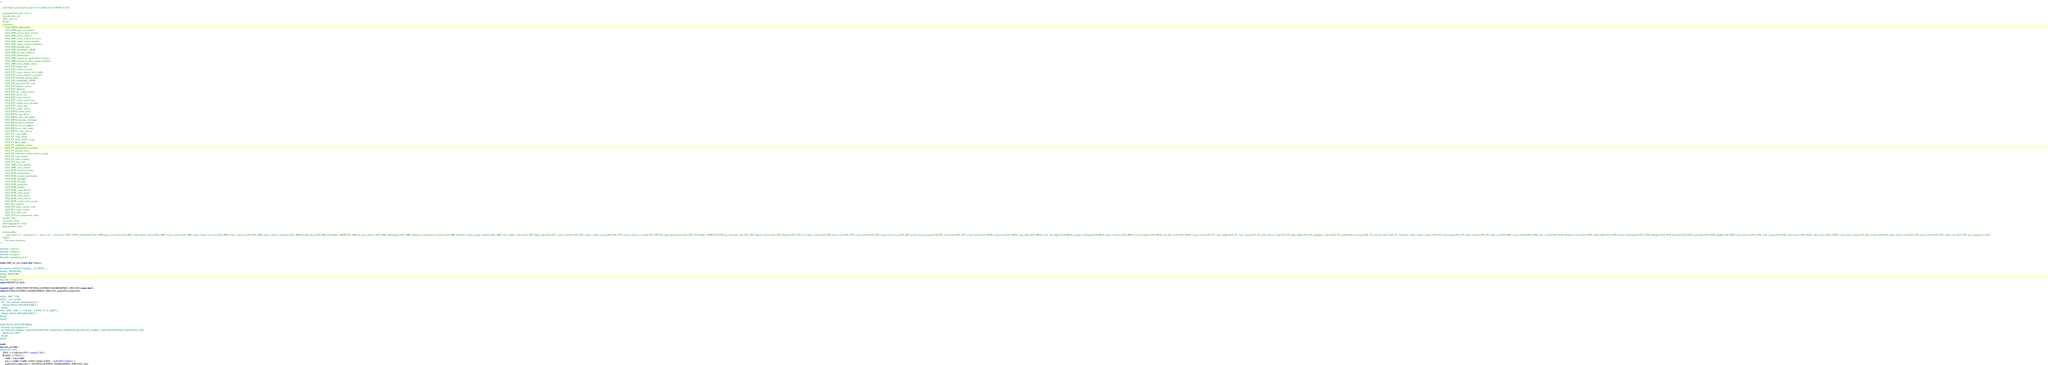Convert code to text. <code><loc_0><loc_0><loc_500><loc_500><_C_>/*

    GLX loader generated by glad 0.1.34 on Mon Jan 18 06:00:03 2021.

    Language/Generator: C/C++
    Specification: glx
    APIs: glx=1.4
    Profile: -
    Extensions:
        GLX_3DFX_multisample,
        GLX_AMD_gpu_association,
        GLX_ARB_context_flush_control,
        GLX_ARB_create_context,
        GLX_ARB_create_context_no_error,
        GLX_ARB_create_context_profile,
        GLX_ARB_create_context_robustness,
        GLX_ARB_fbconfig_float,
        GLX_ARB_framebuffer_sRGB,
        GLX_ARB_get_proc_address,
        GLX_ARB_multisample,
        GLX_ARB_robustness_application_isolation,
        GLX_ARB_robustness_share_group_isolation,
        GLX_ARB_vertex_buffer_object,
        GLX_EXT_buffer_age,
        GLX_EXT_context_priority,
        GLX_EXT_create_context_es2_profile,
        GLX_EXT_create_context_es_profile,
        GLX_EXT_fbconfig_packed_float,
        GLX_EXT_framebuffer_sRGB,
        GLX_EXT_get_drawable_type,
        GLX_EXT_import_context,
        GLX_EXT_libglvnd,
        GLX_EXT_no_config_context,
        GLX_EXT_stereo_tree,
        GLX_EXT_swap_control,
        GLX_EXT_swap_control_tear,
        GLX_EXT_texture_from_pixmap,
        GLX_EXT_visual_info,
        GLX_EXT_visual_rating,
        GLX_INTEL_swap_event,
        GLX_MESA_agp_offset,
        GLX_MESA_copy_sub_buffer,
        GLX_MESA_pixmap_colormap,
        GLX_MESA_query_renderer,
        GLX_MESA_release_buffers,
        GLX_MESA_set_3dfx_mode,
        GLX_MESA_swap_control,
        GLX_NV_copy_buffer,
        GLX_NV_copy_image,
        GLX_NV_delay_before_swap,
        GLX_NV_float_buffer,
        GLX_NV_multigpu_context,
        GLX_NV_multisample_coverage,
        GLX_NV_present_video,
        GLX_NV_robustness_video_memory_purge,
        GLX_NV_swap_group,
        GLX_NV_video_capture,
        GLX_NV_video_out,
        GLX_OML_swap_method,
        GLX_OML_sync_control,
        GLX_SGIS_blended_overlay,
        GLX_SGIS_multisample,
        GLX_SGIS_shared_multisample,
        GLX_SGIX_dmbuffer,
        GLX_SGIX_fbconfig,
        GLX_SGIX_hyperpipe,
        GLX_SGIX_pbuffer,
        GLX_SGIX_swap_barrier,
        GLX_SGIX_swap_group,
        GLX_SGIX_video_resize,
        GLX_SGIX_video_source,
        GLX_SGIX_visual_select_group,
        GLX_SGI_cushion,
        GLX_SGI_make_current_read,
        GLX_SGI_swap_control,
        GLX_SGI_video_sync,
        GLX_SUN_get_transparent_index
    Loader: True
    Local files: False
    Omit khrplatform: False
    Reproducible: False

    Commandline:
        --api="glx=1.4" --generator="c" --spec="glx" --extensions="GLX_3DFX_multisample,GLX_AMD_gpu_association,GLX_ARB_context_flush_control,GLX_ARB_create_context,GLX_ARB_create_context_no_error,GLX_ARB_create_context_profile,GLX_ARB_create_context_robustness,GLX_ARB_fbconfig_float,GLX_ARB_framebuffer_sRGB,GLX_ARB_get_proc_address,GLX_ARB_multisample,GLX_ARB_robustness_application_isolation,GLX_ARB_robustness_share_group_isolation,GLX_ARB_vertex_buffer_object,GLX_EXT_buffer_age,GLX_EXT_context_priority,GLX_EXT_create_context_es2_profile,GLX_EXT_create_context_es_profile,GLX_EXT_fbconfig_packed_float,GLX_EXT_framebuffer_sRGB,GLX_EXT_get_drawable_type,GLX_EXT_import_context,GLX_EXT_libglvnd,GLX_EXT_no_config_context,GLX_EXT_stereo_tree,GLX_EXT_swap_control,GLX_EXT_swap_control_tear,GLX_EXT_texture_from_pixmap,GLX_EXT_visual_info,GLX_EXT_visual_rating,GLX_INTEL_swap_event,GLX_MESA_agp_offset,GLX_MESA_copy_sub_buffer,GLX_MESA_pixmap_colormap,GLX_MESA_query_renderer,GLX_MESA_release_buffers,GLX_MESA_set_3dfx_mode,GLX_MESA_swap_control,GLX_NV_copy_buffer,GLX_NV_copy_image,GLX_NV_delay_before_swap,GLX_NV_float_buffer,GLX_NV_multigpu_context,GLX_NV_multisample_coverage,GLX_NV_present_video,GLX_NV_robustness_video_memory_purge,GLX_NV_swap_group,GLX_NV_video_capture,GLX_NV_video_out,GLX_OML_swap_method,GLX_OML_sync_control,GLX_SGIS_blended_overlay,GLX_SGIS_multisample,GLX_SGIS_shared_multisample,GLX_SGIX_dmbuffer,GLX_SGIX_fbconfig,GLX_SGIX_hyperpipe,GLX_SGIX_pbuffer,GLX_SGIX_swap_barrier,GLX_SGIX_swap_group,GLX_SGIX_video_resize,GLX_SGIX_video_source,GLX_SGIX_visual_select_group,GLX_SGI_cushion,GLX_SGI_make_current_read,GLX_SGI_swap_control,GLX_SGI_video_sync,GLX_SUN_get_transparent_index"
    Online:
        Too many extensions
*/

#include <stdio.h>
#include <stdlib.h>
#include <string.h>
#include <glad/glad_glx.h>

static void* get_proc(const char *namez);

#if defined(_WIN32) || defined(__CYGWIN__)
#ifndef _WINDOWS_
#undef APIENTRY
#endif
#include <windows.h>
static HMODULE libGL;

typedef void* (APIENTRYP PFNWGLGETPROCADDRESSPROC_PRIVATE)(const char*);
static PFNWGLGETPROCADDRESSPROC_PRIVATE gladGetProcAddressPtr;

#ifdef _MSC_VER
#ifdef __has_include
  #if __has_include(<winapifamily.h>)
    #define HAVE_WINAPIFAMILY 1
  #endif
#elif _MSC_VER >= 1700 && !_USING_V110_SDK71_
  #define HAVE_WINAPIFAMILY 1
#endif
#endif

#ifdef HAVE_WINAPIFAMILY
  #include <winapifamily.h>
  #if !WINAPI_FAMILY_PARTITION(WINAPI_PARTITION_DESKTOP) && WINAPI_FAMILY_PARTITION(WINAPI_PARTITION_APP)
    #define IS_UWP 1
  #endif
#endif

static
int open_gl(void) {
#ifndef IS_UWP
    libGL = LoadLibraryW(L"opengl32.dll");
    if(libGL != NULL) {
        void (* tmp)(void);
        tmp = (void(*)(void)) GetProcAddress(libGL, "wglGetProcAddress");
        gladGetProcAddressPtr = (PFNWGLGETPROCADDRESSPROC_PRIVATE) tmp;</code> 